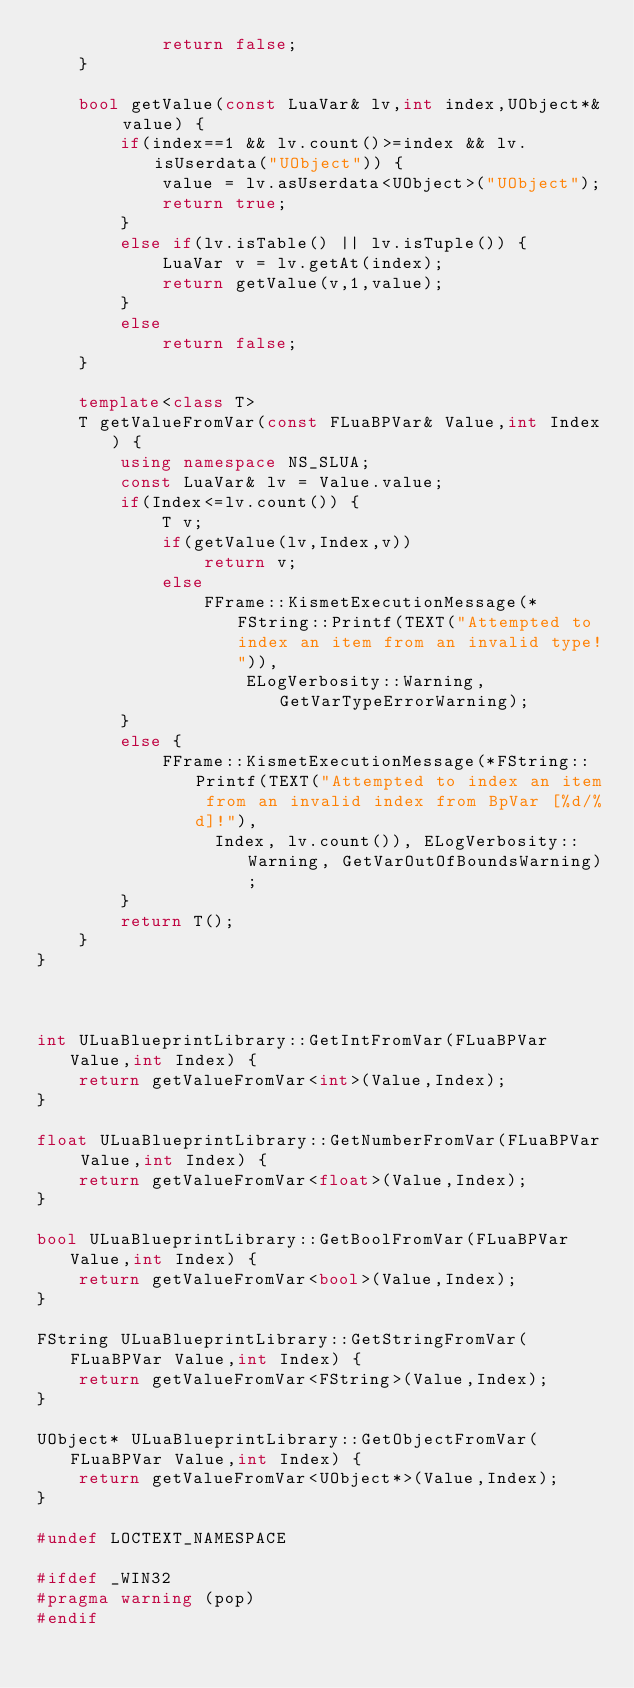Convert code to text. <code><loc_0><loc_0><loc_500><loc_500><_C++_>            return false;
    }

    bool getValue(const LuaVar& lv,int index,UObject*& value) {
        if(index==1 && lv.count()>=index && lv.isUserdata("UObject")) {
            value = lv.asUserdata<UObject>("UObject");
            return true;
        }
        else if(lv.isTable() || lv.isTuple()) {
            LuaVar v = lv.getAt(index);
            return getValue(v,1,value);
        }
        else
            return false;
    }

    template<class T>
    T getValueFromVar(const FLuaBPVar& Value,int Index) {
        using namespace NS_SLUA;
        const LuaVar& lv = Value.value;
        if(Index<=lv.count()) {
            T v;
            if(getValue(lv,Index,v))
                return v;
            else
                FFrame::KismetExecutionMessage(*FString::Printf(TEXT("Attempted to index an item from an invalid type!")),
                    ELogVerbosity::Warning, GetVarTypeErrorWarning);
        }
        else {
            FFrame::KismetExecutionMessage(*FString::Printf(TEXT("Attempted to index an item from an invalid index from BpVar [%d/%d]!"),
                 Index, lv.count()), ELogVerbosity::Warning, GetVarOutOfBoundsWarning);
        }
        return T();
    }
}



int ULuaBlueprintLibrary::GetIntFromVar(FLuaBPVar Value,int Index) {
    return getValueFromVar<int>(Value,Index);
}

float ULuaBlueprintLibrary::GetNumberFromVar(FLuaBPVar Value,int Index) {
    return getValueFromVar<float>(Value,Index);
}

bool ULuaBlueprintLibrary::GetBoolFromVar(FLuaBPVar Value,int Index) {
    return getValueFromVar<bool>(Value,Index);
}

FString ULuaBlueprintLibrary::GetStringFromVar(FLuaBPVar Value,int Index) {
    return getValueFromVar<FString>(Value,Index);
}

UObject* ULuaBlueprintLibrary::GetObjectFromVar(FLuaBPVar Value,int Index) {
    return getValueFromVar<UObject*>(Value,Index);
}

#undef LOCTEXT_NAMESPACE

#ifdef _WIN32
#pragma warning (pop)
#endif</code> 